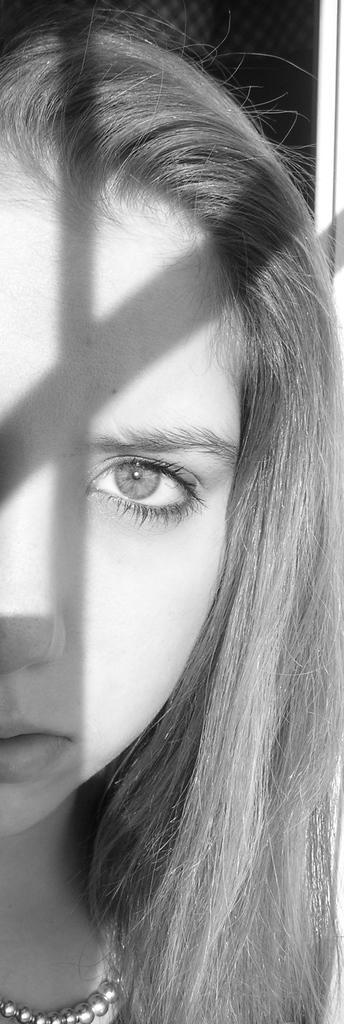How would you summarize this image in a sentence or two? In this image I can see the black and white picture of a woman who is wearing a chain which is silver in color in her neck and I can see the black background. 